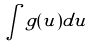Convert formula to latex. <formula><loc_0><loc_0><loc_500><loc_500>\int g ( u ) d u</formula> 